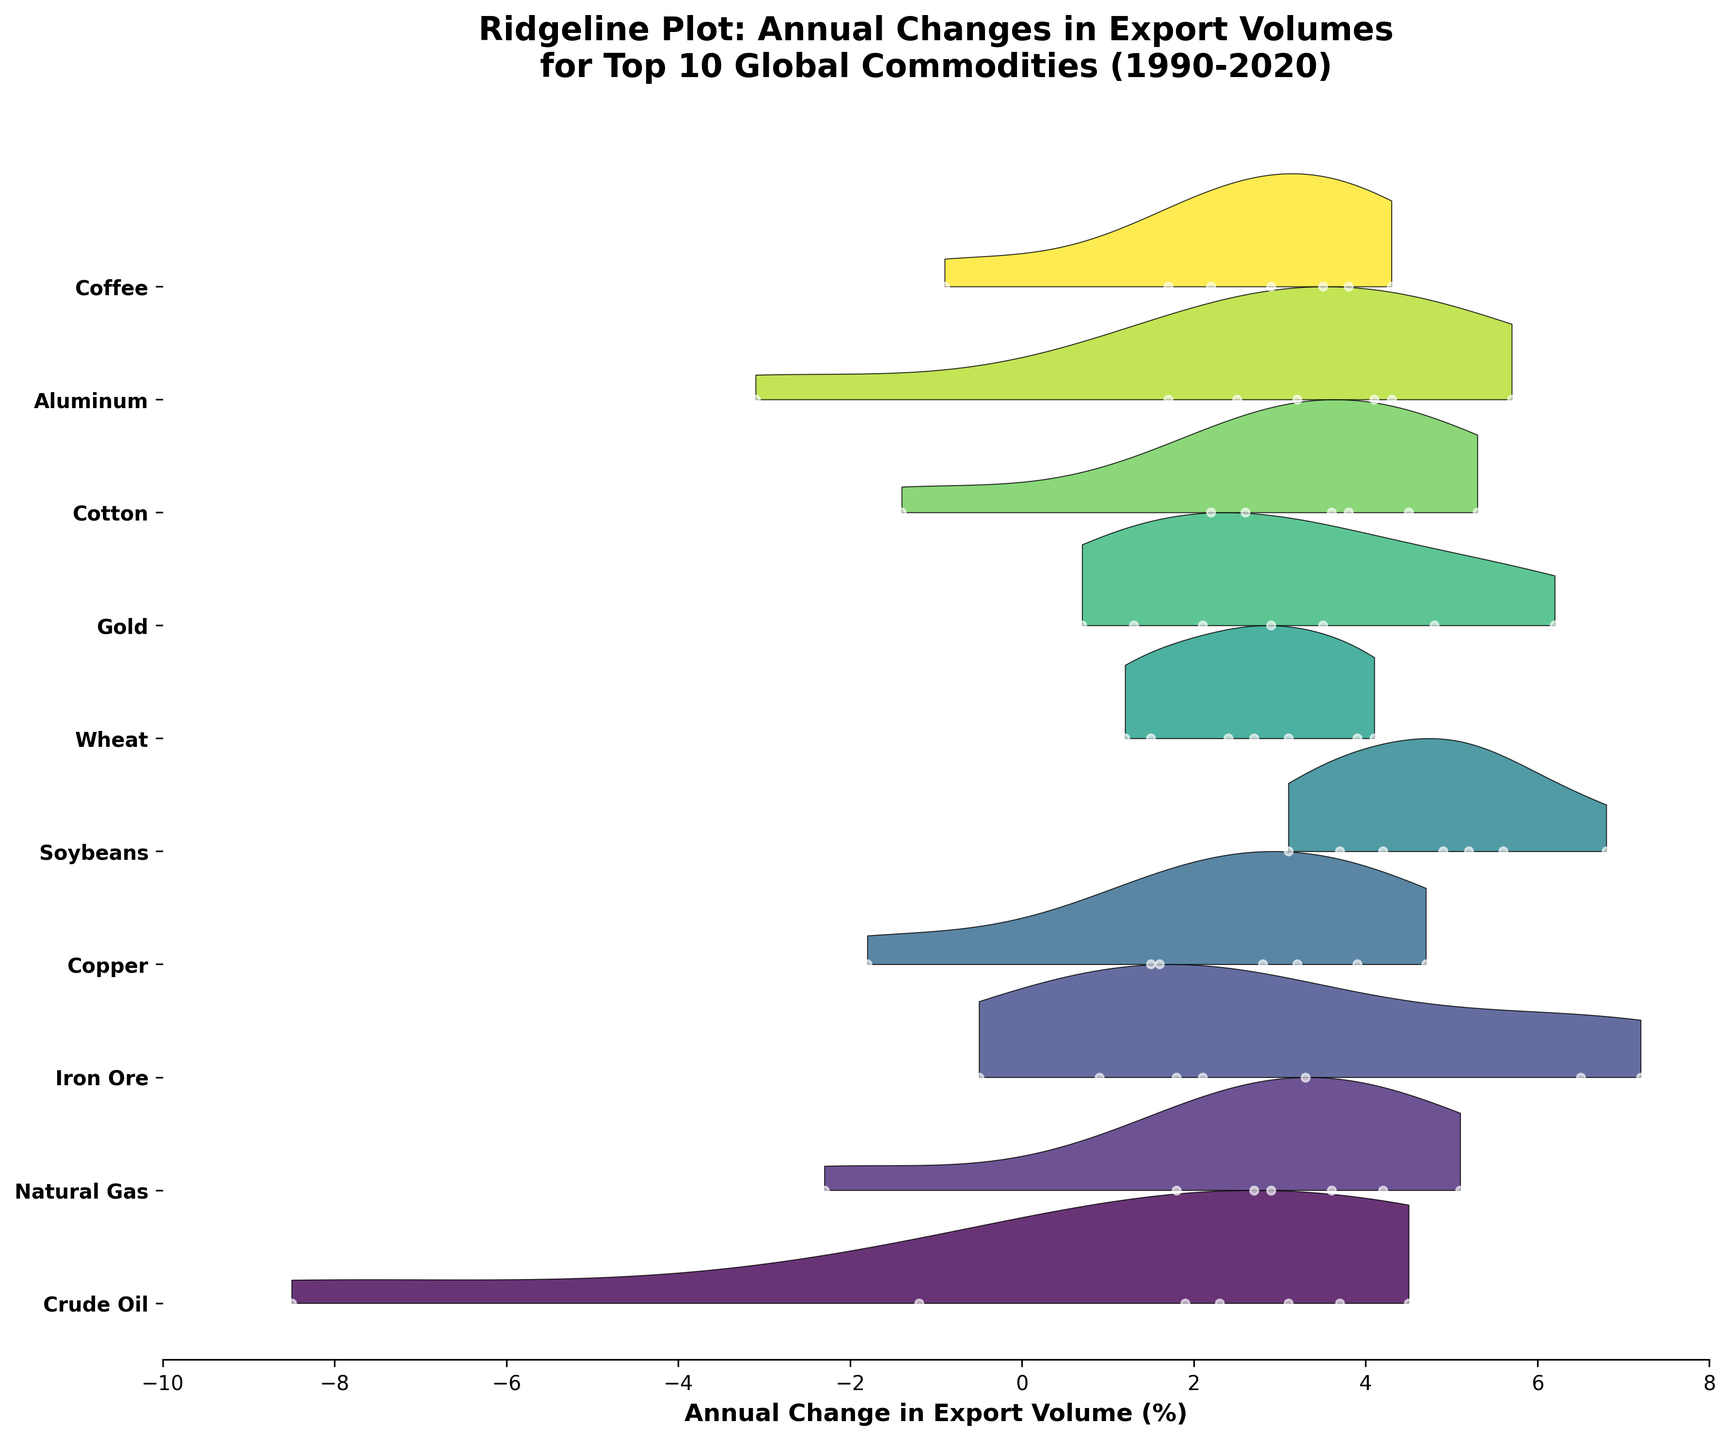What is the title of the plot? The title of the plot is prominently displayed at the top. It reads: 'Ridgeline Plot: Annual Changes in Export Volumes for Top 10 Global Commodities (1990-2020)'
Answer: Ridgeline Plot: Annual Changes in Export Volumes for Top 10 Global Commodities (1990-2020) Which axis represents the annual change in export volume? By examining the figure, it's clear that the horizontal axis (x-axis) represents the annual change in export volume. This is indicated by the label on that axis.
Answer: Horizontal axis (x-axis) How are the commodities represented on the plot? Each commodity is represented as a distinct ridgeline on the plot, differentiated by color and label along the vertical axis (y-axis).
Answer: Ridgelines Which commodity experienced the largest drop in export volume in 2020? Looking along the 2020 data points, Crude Oil had the most significant negative volume change at -8.5%, visible at the bottom of the ridgeline for that year.
Answer: Crude Oil How are the peaks of the ridgelines differentiated from each other? The peaks of the ridgelines are differentiated by colors and the magnitude of the density estimated by the KDE, which changes with the height of each ridgeline plot.
Answer: Color and height Which commodity shows a consistently positive and increasing export volume change trend throughout the years? By observing the ridgeline plots, Soybeans consistently show an increasing and predominantly positive volume change throughout most years.
Answer: Soybeans What was the approximate export volume change for Natural Gas in 2010? On the ridgeline for Natural Gas in 2010, the data point indicates an annual export volume change of around approximately 5.1%.
Answer: 5.1% Identify the commodity with the highest peak in their ridgeline plot. The highest peak can be seen in the ridgeline plot for Gold, especially near the 2020 mark where the export volume change is the highest compared to other commodities.
Answer: Gold Compare and identify the commodity that faced a negative change in the export volume in 2020 besides Crude Oil. Both the ridgeline plots and the data points show that besides Crude Oil, Natural Gas, Cotton, Aluminum, and Coffee also faced negative changes in 2020.
Answer: Natural Gas, Cotton, Aluminum, and Coffee How are changes in export volumes visually represented along the ridgelines? Changes in export volumes are represented by the density and height of the ridgelines, with specific data points plotted as white dots along the x-axis for each year.
Answer: Density, height, and white dots 